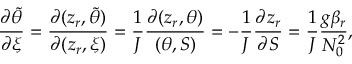Convert formula to latex. <formula><loc_0><loc_0><loc_500><loc_500>\frac { \partial \tilde { \theta } } { \partial \xi } = \frac { \partial ( z _ { r } , \tilde { \theta } ) } { \partial ( z _ { r } , \xi ) } = \frac { 1 } { J } \frac { \partial ( z _ { r } , \theta ) } { ( \theta , S ) } = - \frac { 1 } { J } \frac { \partial z _ { r } } { \partial S } = \frac { 1 } { J } \frac { g \beta _ { r } } { N _ { 0 } ^ { 2 } } ,</formula> 